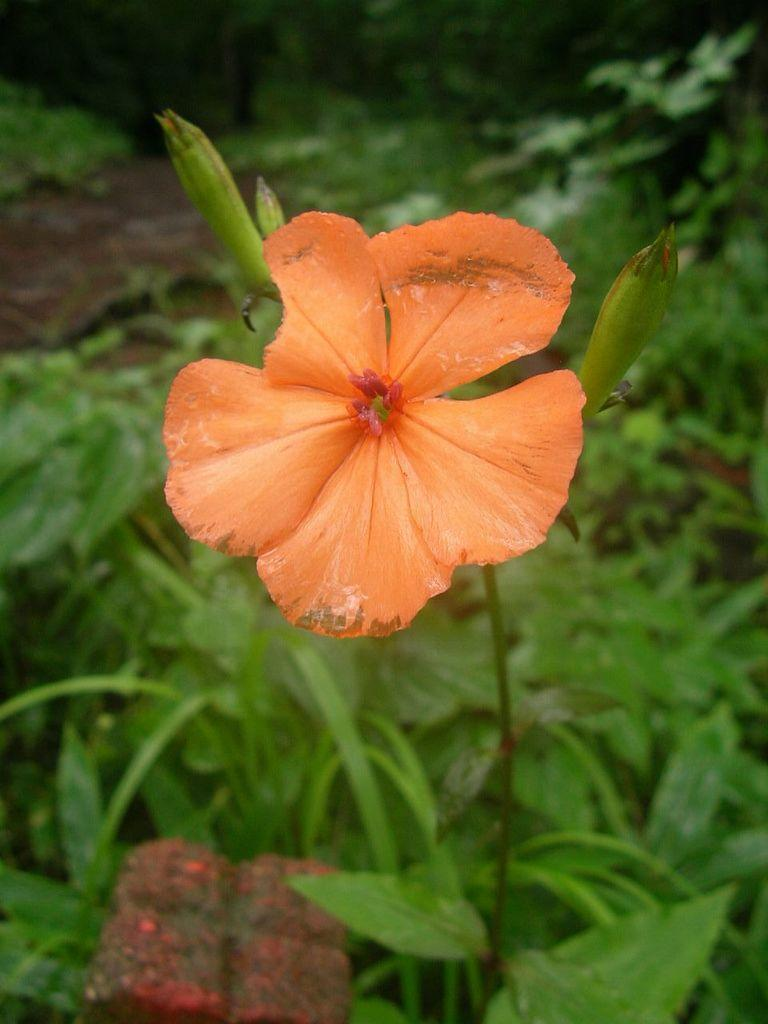What is the main subject in the middle of the image? There is a flower with a stem in the middle of the image. What can be seen in the background of the image? There are plants in the background of the image. What type of sack can be seen hanging from the flower in the image? There is no sack present in the image, and the flower is not hanging from anything. 